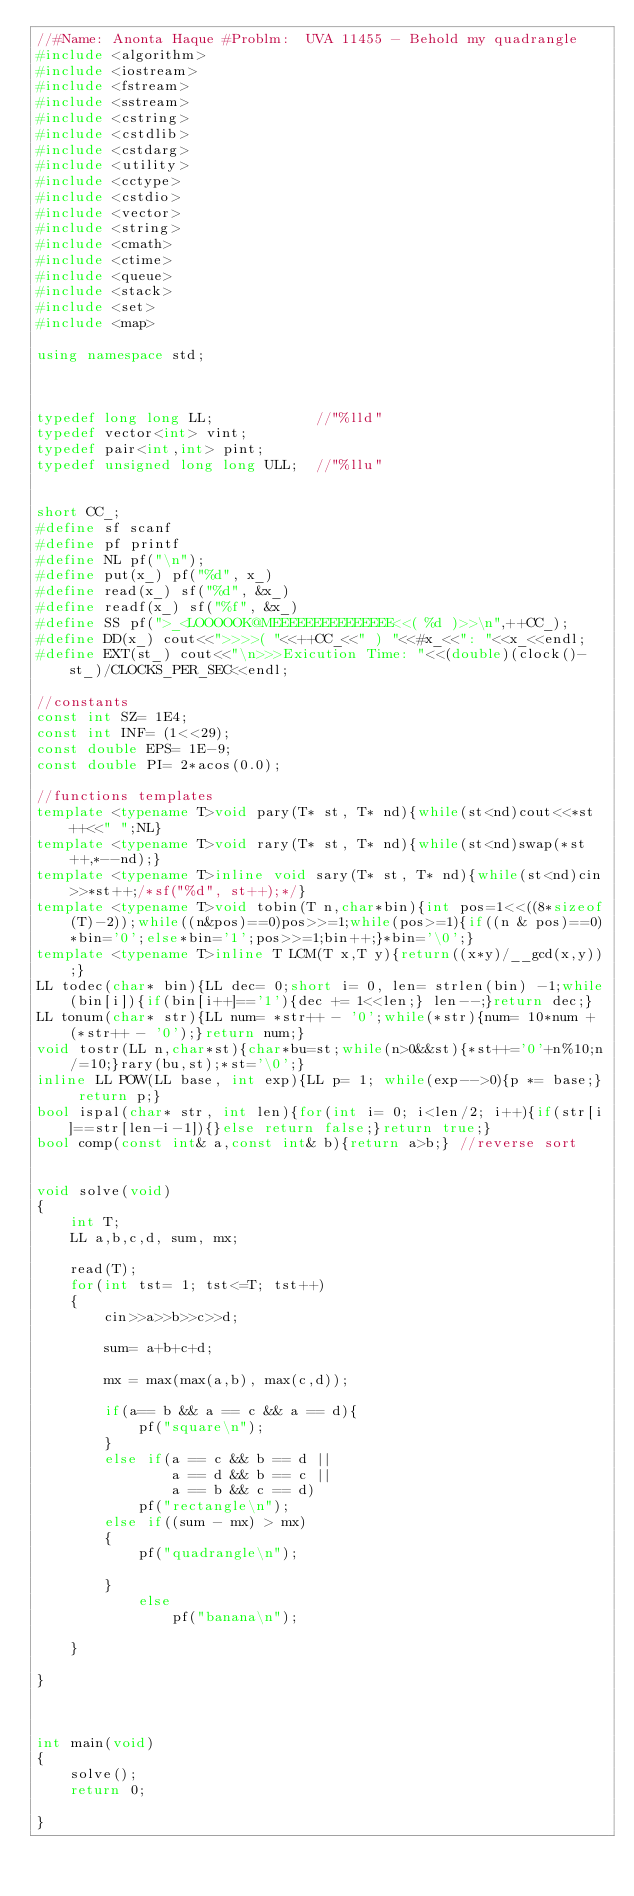<code> <loc_0><loc_0><loc_500><loc_500><_C++_>//#Name: Anonta Haque #Problm:  UVA 11455 - Behold my quadrangle
#include <algorithm>
#include <iostream>
#include <fstream>
#include <sstream>
#include <cstring>
#include <cstdlib>
#include <cstdarg>
#include <utility>
#include <cctype>
#include <cstdio>
#include <vector>
#include <string>
#include <cmath>
#include <ctime>
#include <queue>
#include <stack>
#include <set>
#include <map>

using namespace std;



typedef long long LL;            //"%lld"
typedef vector<int> vint;
typedef pair<int,int> pint;
typedef unsigned long long ULL;  //"%llu"


short CC_;
#define sf scanf
#define pf printf
#define NL pf("\n");
#define put(x_) pf("%d", x_)
#define read(x_) sf("%d", &x_)
#define readf(x_) sf("%f", &x_)
#define SS pf(">_<LOOOOOK@MEEEEEEEEEEEEEEE<<( %d )>>\n",++CC_);
#define DD(x_) cout<<">>>>( "<<++CC_<<" ) "<<#x_<<": "<<x_<<endl;
#define EXT(st_) cout<<"\n>>>Exicution Time: "<<(double)(clock()-st_)/CLOCKS_PER_SEC<<endl;

//constants
const int SZ= 1E4;
const int INF= (1<<29);
const double EPS= 1E-9;
const double PI= 2*acos(0.0);

//functions templates
template <typename T>void pary(T* st, T* nd){while(st<nd)cout<<*st++<<" ";NL}
template <typename T>void rary(T* st, T* nd){while(st<nd)swap(*st++,*--nd);}
template <typename T>inline void sary(T* st, T* nd){while(st<nd)cin>>*st++;/*sf("%d", st++);*/}
template <typename T>void tobin(T n,char*bin){int pos=1<<((8*sizeof(T)-2));while((n&pos)==0)pos>>=1;while(pos>=1){if((n & pos)==0)*bin='0';else*bin='1';pos>>=1;bin++;}*bin='\0';}
template <typename T>inline T LCM(T x,T y){return((x*y)/__gcd(x,y));}
LL todec(char* bin){LL dec= 0;short i= 0, len= strlen(bin) -1;while(bin[i]){if(bin[i++]=='1'){dec += 1<<len;} len--;}return dec;}
LL tonum(char* str){LL num= *str++ - '0';while(*str){num= 10*num + (*str++ - '0');}return num;}
void tostr(LL n,char*st){char*bu=st;while(n>0&&st){*st++='0'+n%10;n/=10;}rary(bu,st);*st='\0';}
inline LL POW(LL base, int exp){LL p= 1; while(exp-->0){p *= base;} return p;}
bool ispal(char* str, int len){for(int i= 0; i<len/2; i++){if(str[i]==str[len-i-1]){}else return false;}return true;}
bool comp(const int& a,const int& b){return a>b;} //reverse sort


void solve(void)
{
    int T;
    LL a,b,c,d, sum, mx;
 
    read(T);
    for(int tst= 1; tst<=T; tst++)
    {
        cin>>a>>b>>c>>d;
        
        sum= a+b+c+d;
        
        mx = max(max(a,b), max(c,d));
        
        if(a== b && a == c && a == d){
            pf("square\n");
        }
        else if(a == c && b == d ||
                a == d && b == c ||
                a == b && c == d)
            pf("rectangle\n");
        else if((sum - mx) > mx)
        {
            pf("quadrangle\n");
            
        }
            else
                pf("banana\n");
    
    }
    
}



int main(void)
{
    solve();
    return 0;
    
}



</code> 